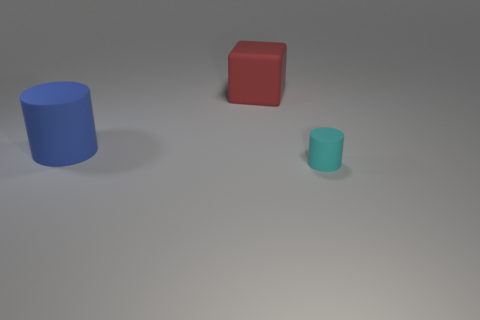Is there any other thing that has the same size as the cyan cylinder?
Keep it short and to the point. No. Is the large block the same color as the small object?
Offer a terse response. No. There is a red block that is the same size as the blue object; what is its material?
Your response must be concise. Rubber. Are the blue thing and the big red object made of the same material?
Your answer should be very brief. Yes. How many tiny things are the same material as the big cylinder?
Provide a succinct answer. 1. How many objects are either objects to the right of the big red matte cube or large rubber objects that are in front of the large cube?
Your answer should be compact. 2. Is the number of cyan matte cylinders that are right of the small rubber thing greater than the number of blue objects in front of the blue cylinder?
Your answer should be very brief. No. There is a rubber thing to the right of the block; what is its color?
Make the answer very short. Cyan. Are there any other large blue matte things that have the same shape as the big blue matte object?
Your answer should be compact. No. What number of blue things are large blocks or rubber balls?
Provide a succinct answer. 0. 